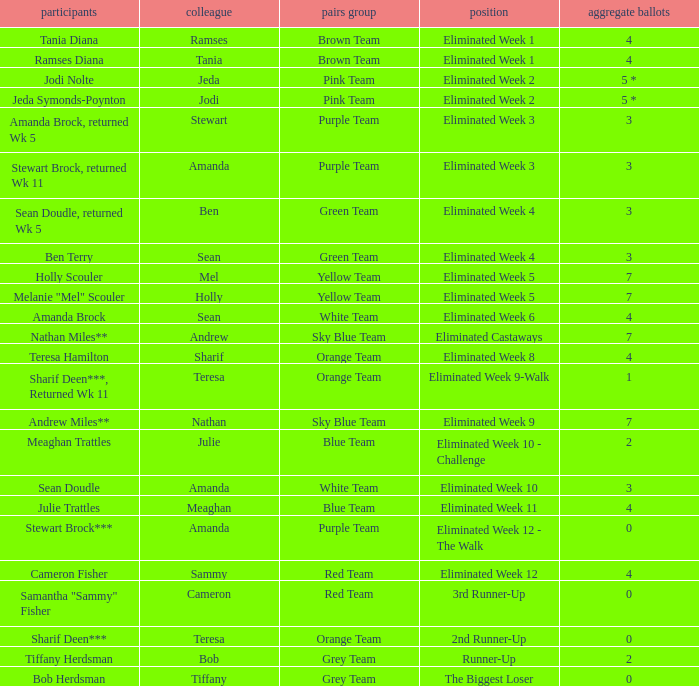What were Holly Scouler's total votes? 7.0. 